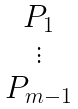<formula> <loc_0><loc_0><loc_500><loc_500>\begin{matrix} P _ { 1 } \\ \vdots \\ P _ { m - 1 } \end{matrix}</formula> 